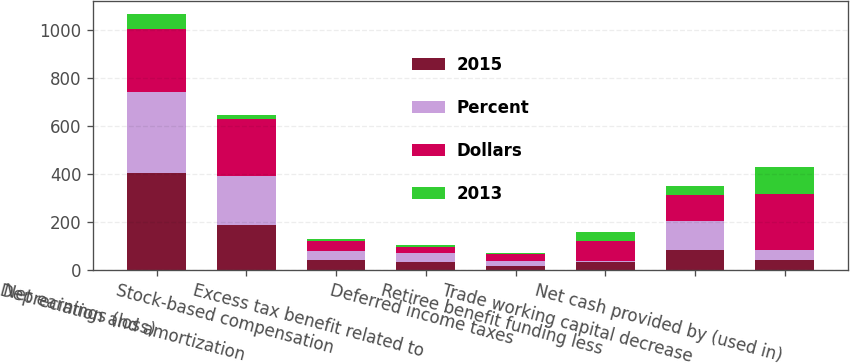Convert chart. <chart><loc_0><loc_0><loc_500><loc_500><stacked_bar_chart><ecel><fcel>Net earnings (loss)<fcel>Depreciation and amortization<fcel>Stock-based compensation<fcel>Excess tax benefit related to<fcel>Deferred income taxes<fcel>Retiree benefit funding less<fcel>Trade working capital decrease<fcel>Net cash provided by (used in)<nl><fcel>2015<fcel>404<fcel>188<fcel>43<fcel>33<fcel>15<fcel>32<fcel>84<fcel>41<nl><fcel>Percent<fcel>338<fcel>205<fcel>34<fcel>39<fcel>22<fcel>4<fcel>120<fcel>41<nl><fcel>Dollars<fcel>261<fcel>235<fcel>44<fcel>24<fcel>28<fcel>86<fcel>108<fcel>236<nl><fcel>2013<fcel>66<fcel>17<fcel>9<fcel>6<fcel>7<fcel>36<fcel>36<fcel>112<nl></chart> 